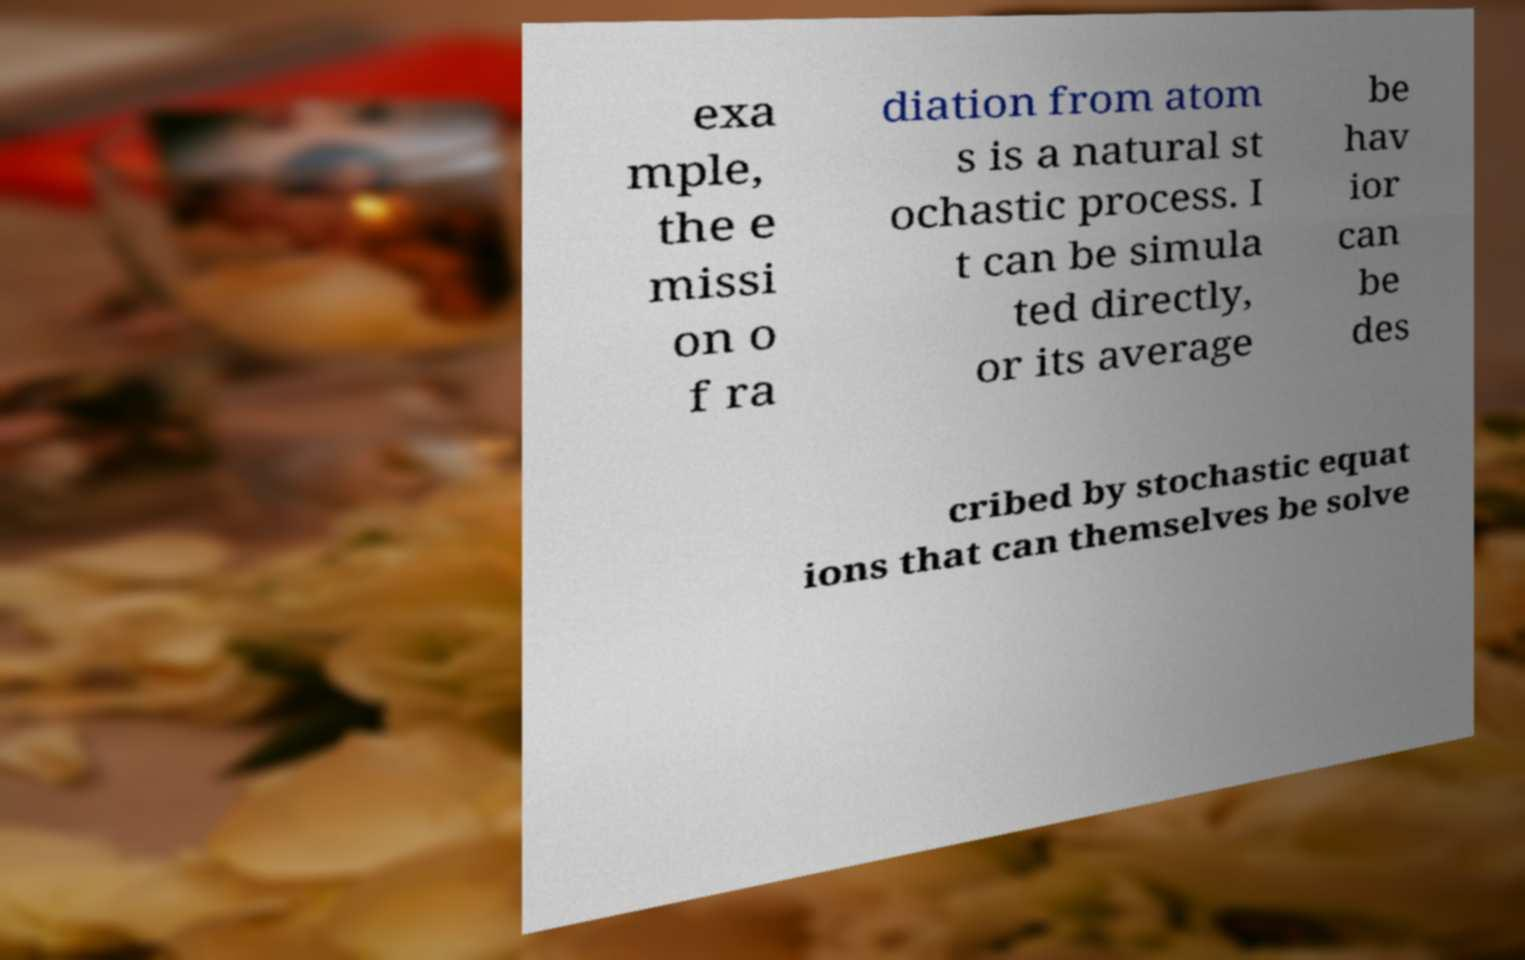Could you assist in decoding the text presented in this image and type it out clearly? exa mple, the e missi on o f ra diation from atom s is a natural st ochastic process. I t can be simula ted directly, or its average be hav ior can be des cribed by stochastic equat ions that can themselves be solve 